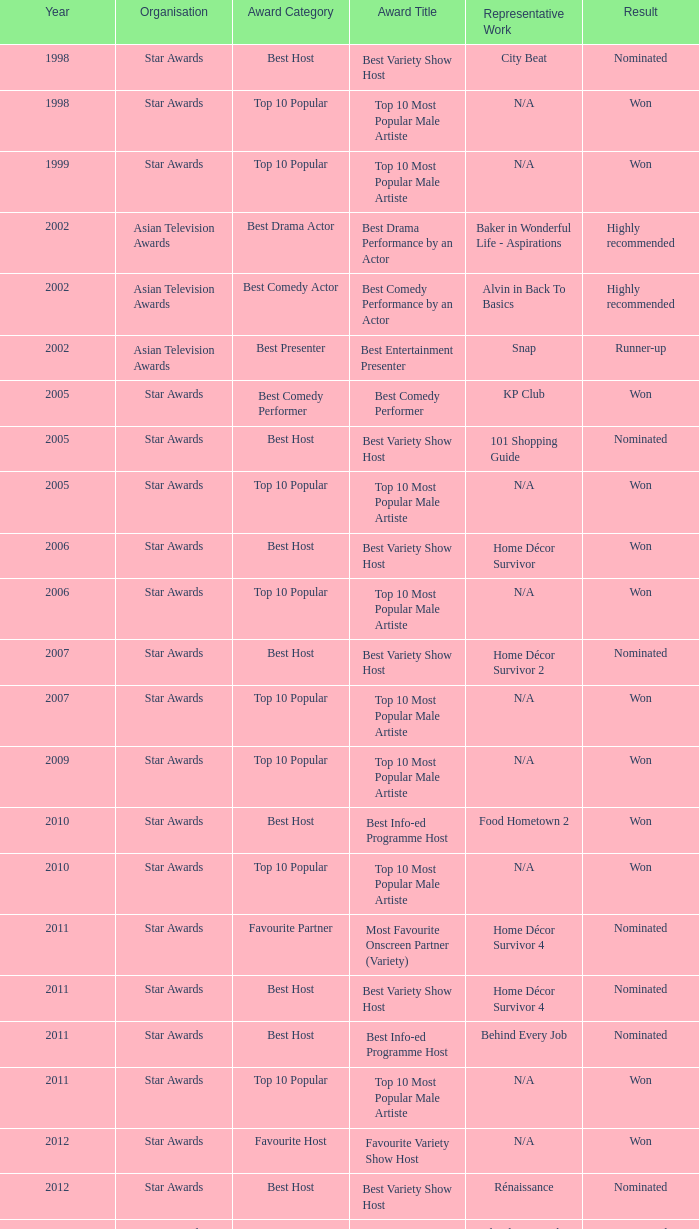What is the name of the award in a year more than 2005, and the Result of nominated? Best Variety Show Host, Most Favourite Onscreen Partner (Variety), Best Variety Show Host, Best Info-ed Programme Host, Best Variety Show Host, Best Info-ed Programme Host, Best Info-Ed Programme Host, Best Variety Show Host. 